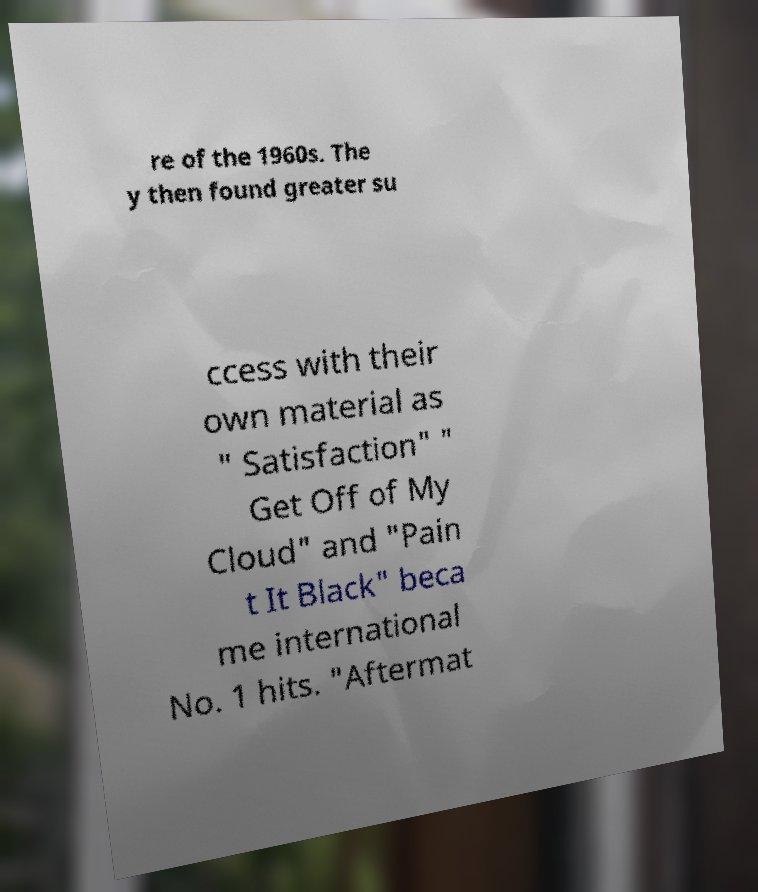Could you extract and type out the text from this image? re of the 1960s. The y then found greater su ccess with their own material as " Satisfaction" " Get Off of My Cloud" and "Pain t It Black" beca me international No. 1 hits. "Aftermat 